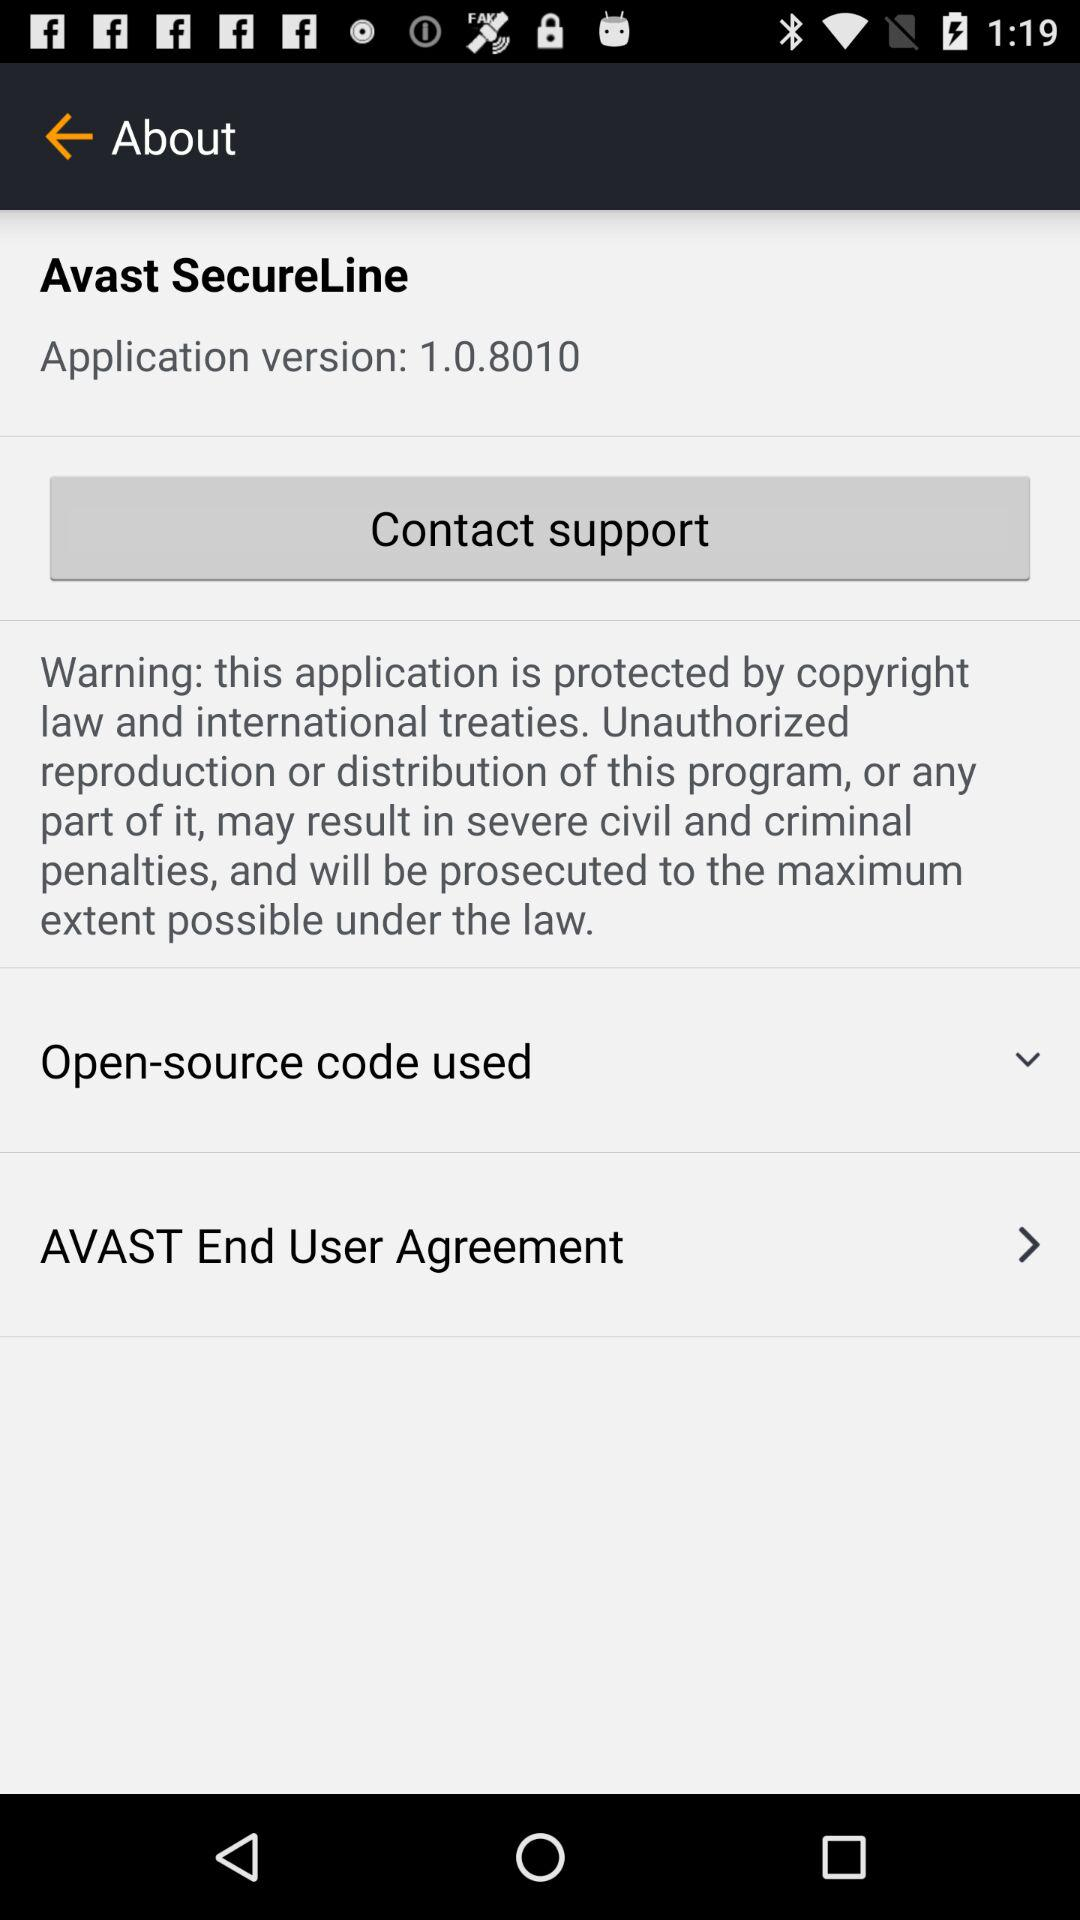How do you contact support?
When the provided information is insufficient, respond with <no answer>. <no answer> 